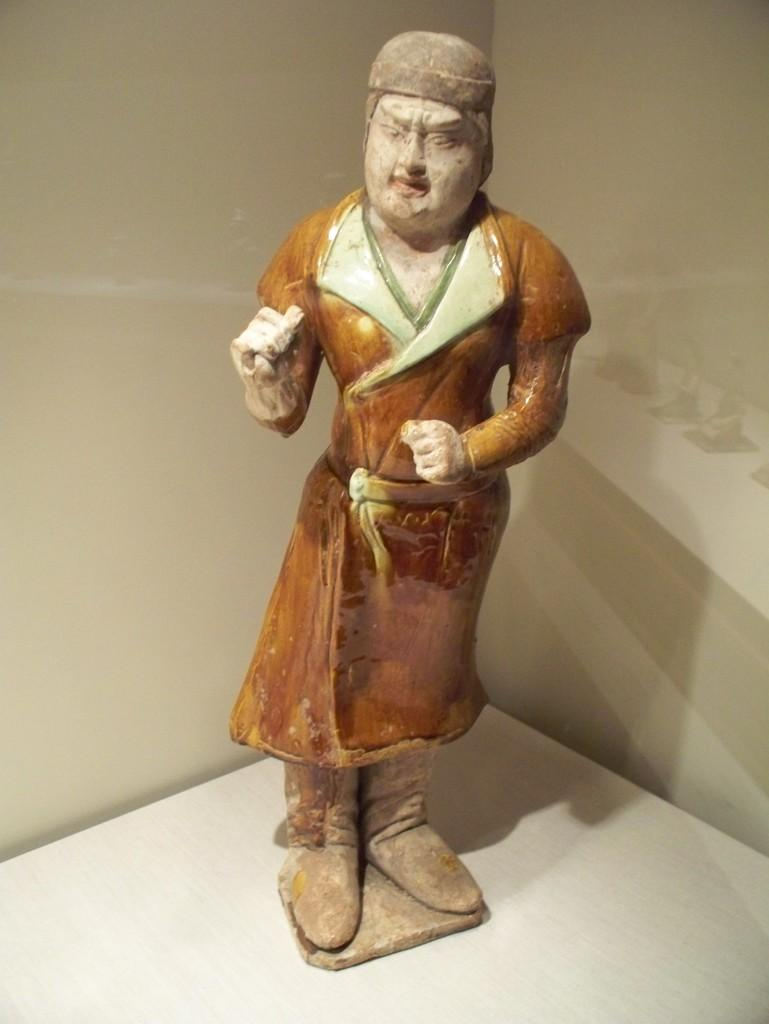What is the main subject in the foreground of the image? There is a person's sculpture in the foreground of the image. Where is the sculpture located? The sculpture is on the floor. What can be seen in the background of the image? There is a wall in the background of the image. Can you describe the possible location of the image? The image may have been taken in a hall. What type of store can be seen in the image? There is no store present in the image; it features a person's sculpture on the floor with a wall in the background. How many people are visible in the image? The image does not depict any people; it only shows a person's sculpture on the floor. 